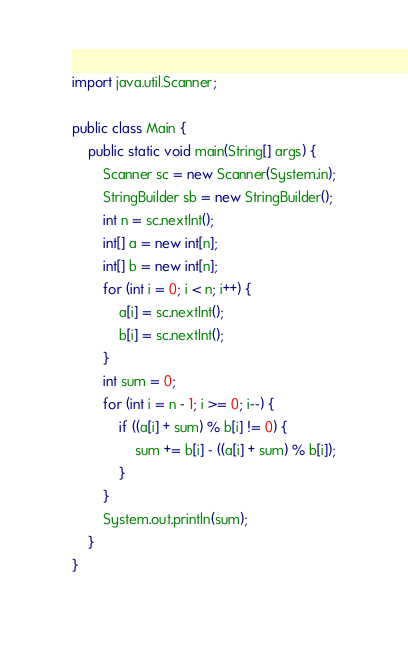<code> <loc_0><loc_0><loc_500><loc_500><_Java_>import java.util.Scanner;

public class Main {
	public static void main(String[] args) {
		Scanner sc = new Scanner(System.in);
		StringBuilder sb = new StringBuilder();
		int n = sc.nextInt();
		int[] a = new int[n];
		int[] b = new int[n];
		for (int i = 0; i < n; i++) {
			a[i] = sc.nextInt();
			b[i] = sc.nextInt();
		}
		int sum = 0;
		for (int i = n - 1; i >= 0; i--) {
			if ((a[i] + sum) % b[i] != 0) {
				sum += b[i] - ((a[i] + sum) % b[i]);
			}
		}
		System.out.println(sum);
	}
}
</code> 